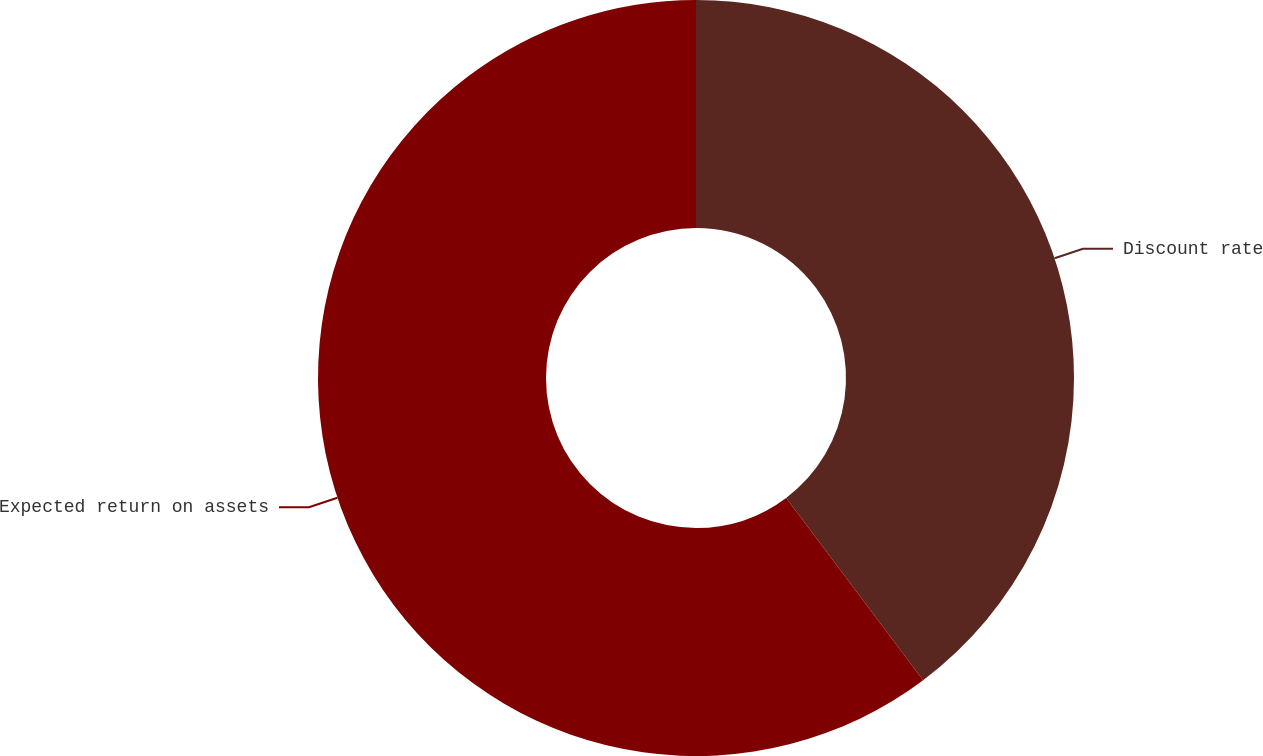Convert chart. <chart><loc_0><loc_0><loc_500><loc_500><pie_chart><fcel>Discount rate<fcel>Expected return on assets<nl><fcel>39.74%<fcel>60.26%<nl></chart> 